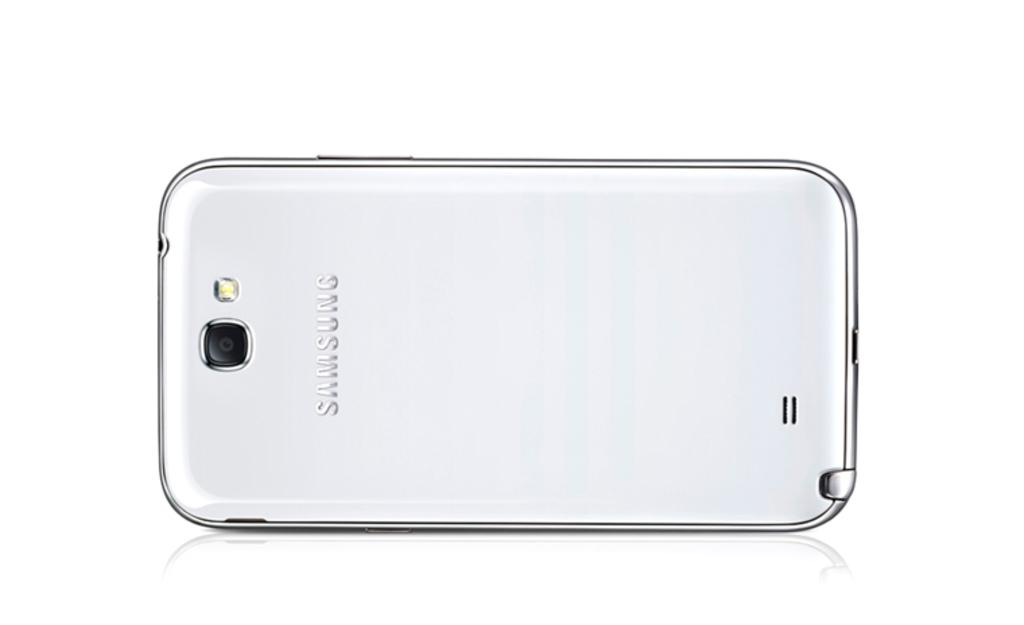Provide a one-sentence caption for the provided image. A slick silver Samsung phone has the company name on its back. 